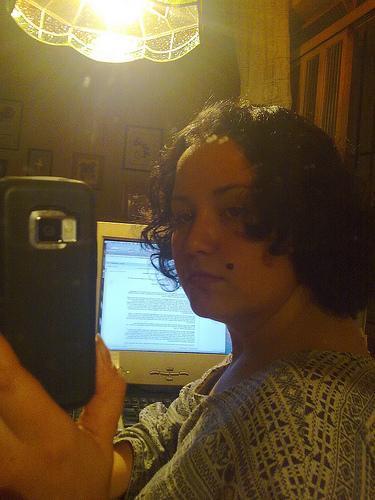How many lights are on?
Give a very brief answer. 1. 